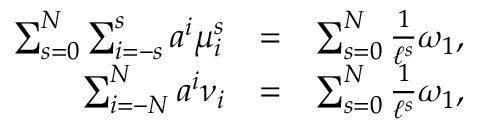<formula> <loc_0><loc_0><loc_500><loc_500>\begin{array} { r l r } { \sum _ { s = 0 } ^ { N } \sum _ { i = - s } ^ { s } a ^ { i } \mu _ { i } ^ { s } } & { = } & { \sum _ { s = 0 } ^ { N } \frac { 1 } { \ell ^ { s } } \omega _ { 1 } , } \\ { \sum _ { i = - N } ^ { N } a ^ { i } \nu _ { i } } & { = } & { \sum _ { s = 0 } ^ { N } \frac { 1 } { \ell ^ { s } } \omega _ { 1 } , } \end{array}</formula> 